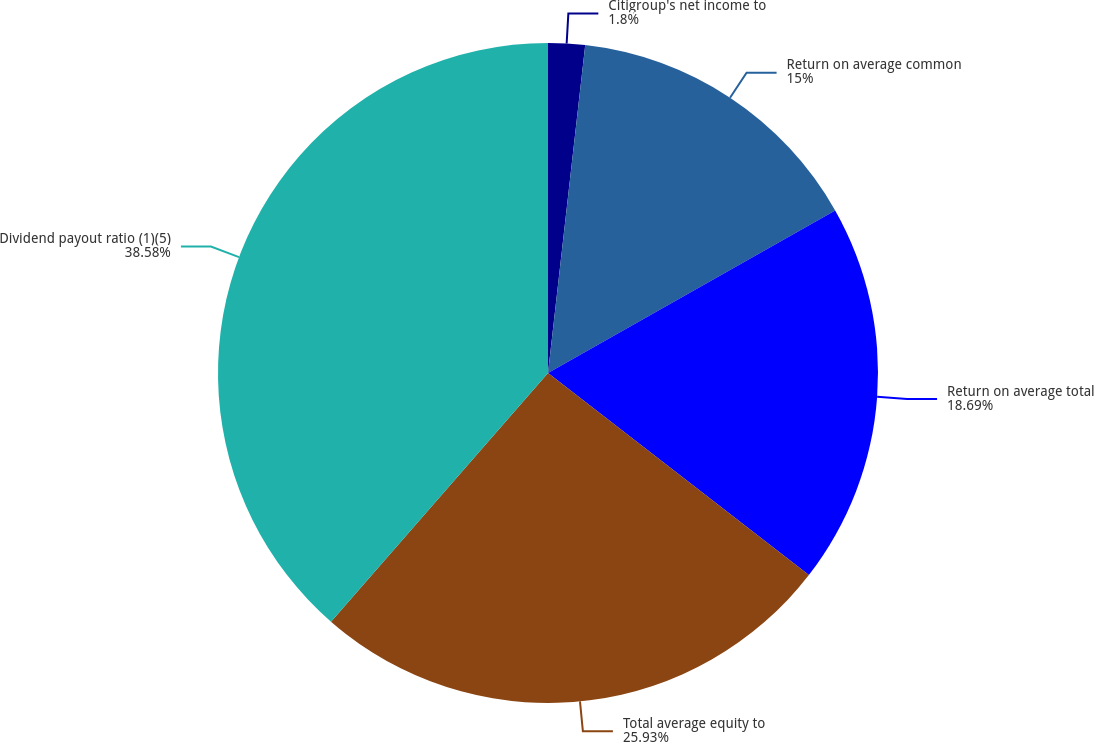<chart> <loc_0><loc_0><loc_500><loc_500><pie_chart><fcel>Citigroup's net income to<fcel>Return on average common<fcel>Return on average total<fcel>Total average equity to<fcel>Dividend payout ratio (1)(5)<nl><fcel>1.8%<fcel>15.0%<fcel>18.69%<fcel>25.93%<fcel>38.58%<nl></chart> 